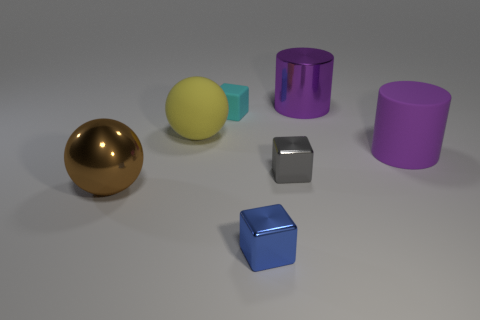How many big metallic objects are the same color as the large matte cylinder?
Your answer should be very brief. 1. Is the metallic cylinder the same color as the rubber cylinder?
Provide a succinct answer. Yes. There is a large object that is the same color as the matte cylinder; what material is it?
Your response must be concise. Metal. The ball that is made of the same material as the gray object is what color?
Provide a short and direct response. Brown. The thing that is to the right of the big metallic thing on the right side of the big metal thing in front of the yellow matte object is made of what material?
Offer a very short reply. Rubber. There is a cylinder behind the purple matte cylinder; is its size the same as the big purple matte thing?
Ensure brevity in your answer.  Yes. How many tiny things are brown metallic things or spheres?
Your answer should be very brief. 0. Is there a matte sphere that has the same color as the shiny ball?
Keep it short and to the point. No. What is the shape of the brown thing that is the same size as the yellow sphere?
Keep it short and to the point. Sphere. Is the color of the big metal object that is in front of the big purple metallic cylinder the same as the big metallic cylinder?
Provide a short and direct response. No. 